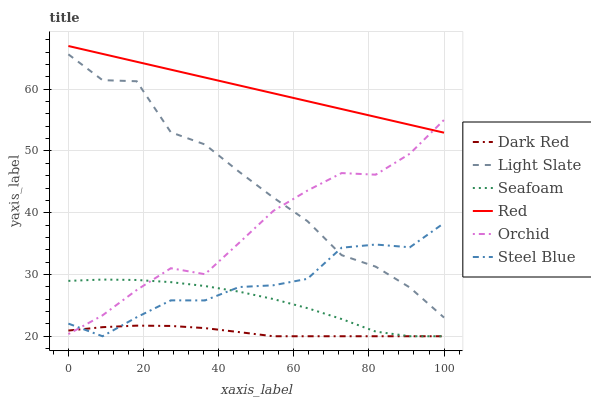Does Dark Red have the minimum area under the curve?
Answer yes or no. Yes. Does Red have the maximum area under the curve?
Answer yes or no. Yes. Does Steel Blue have the minimum area under the curve?
Answer yes or no. No. Does Steel Blue have the maximum area under the curve?
Answer yes or no. No. Is Red the smoothest?
Answer yes or no. Yes. Is Light Slate the roughest?
Answer yes or no. Yes. Is Dark Red the smoothest?
Answer yes or no. No. Is Dark Red the roughest?
Answer yes or no. No. Does Dark Red have the lowest value?
Answer yes or no. Yes. Does Red have the lowest value?
Answer yes or no. No. Does Red have the highest value?
Answer yes or no. Yes. Does Steel Blue have the highest value?
Answer yes or no. No. Is Seafoam less than Red?
Answer yes or no. Yes. Is Red greater than Seafoam?
Answer yes or no. Yes. Does Dark Red intersect Orchid?
Answer yes or no. Yes. Is Dark Red less than Orchid?
Answer yes or no. No. Is Dark Red greater than Orchid?
Answer yes or no. No. Does Seafoam intersect Red?
Answer yes or no. No. 